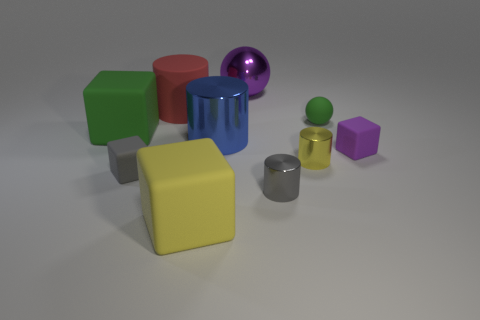Subtract 1 cubes. How many cubes are left? 3 Subtract all blocks. How many objects are left? 6 Add 3 gray cubes. How many gray cubes exist? 4 Subtract 0 blue cubes. How many objects are left? 10 Subtract all purple balls. Subtract all metal balls. How many objects are left? 8 Add 2 large purple things. How many large purple things are left? 3 